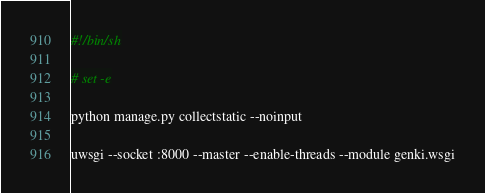<code> <loc_0><loc_0><loc_500><loc_500><_Bash_>#!/bin/sh

# set -e

python manage.py collectstatic --noinput

uwsgi --socket :8000 --master --enable-threads --module genki.wsgi</code> 